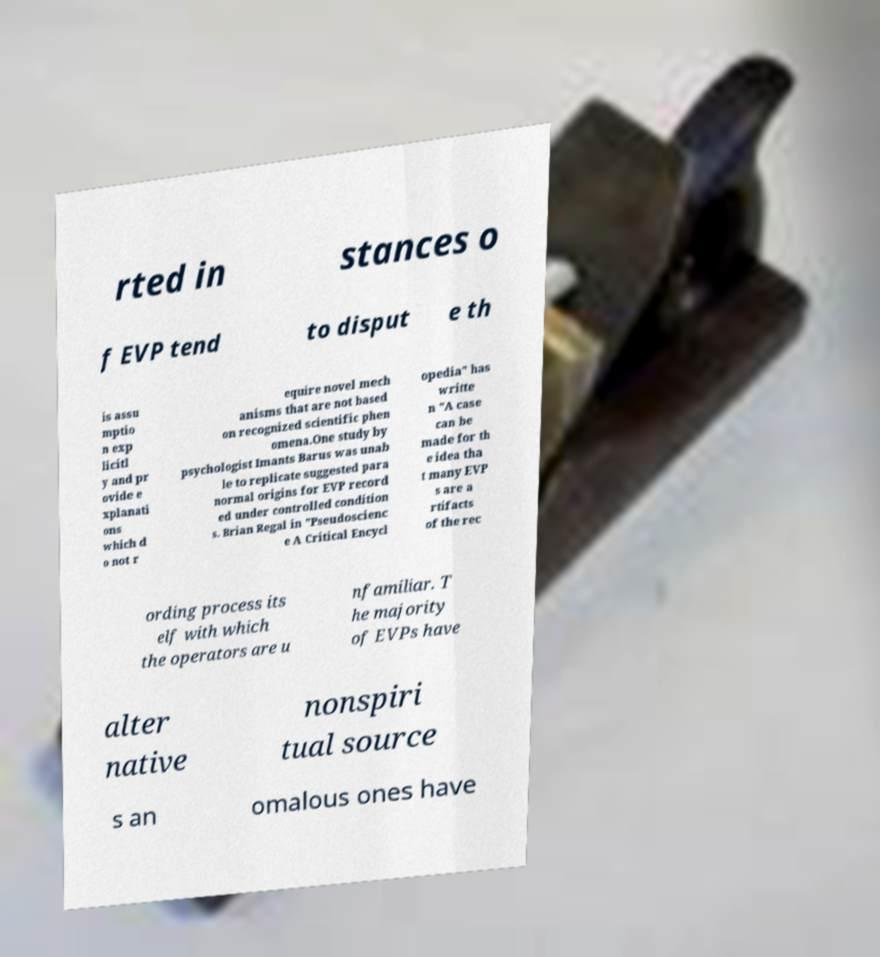I need the written content from this picture converted into text. Can you do that? rted in stances o f EVP tend to disput e th is assu mptio n exp licitl y and pr ovide e xplanati ons which d o not r equire novel mech anisms that are not based on recognized scientific phen omena.One study by psychologist Imants Barus was unab le to replicate suggested para normal origins for EVP record ed under controlled condition s. Brian Regal in "Pseudoscienc e A Critical Encycl opedia" has writte n "A case can be made for th e idea tha t many EVP s are a rtifacts of the rec ording process its elf with which the operators are u nfamiliar. T he majority of EVPs have alter native nonspiri tual source s an omalous ones have 